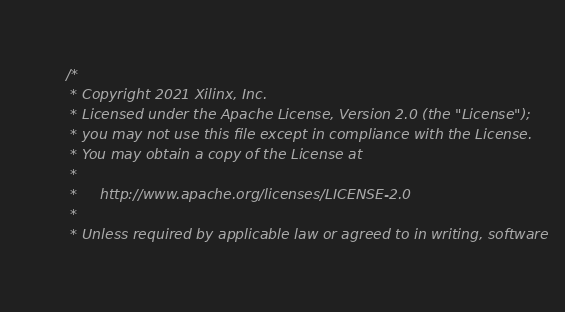Convert code to text. <code><loc_0><loc_0><loc_500><loc_500><_C++_>/*
 * Copyright 2021 Xilinx, Inc.
 * Licensed under the Apache License, Version 2.0 (the "License");
 * you may not use this file except in compliance with the License.
 * You may obtain a copy of the License at
 *
 *     http://www.apache.org/licenses/LICENSE-2.0
 *
 * Unless required by applicable law or agreed to in writing, software</code> 